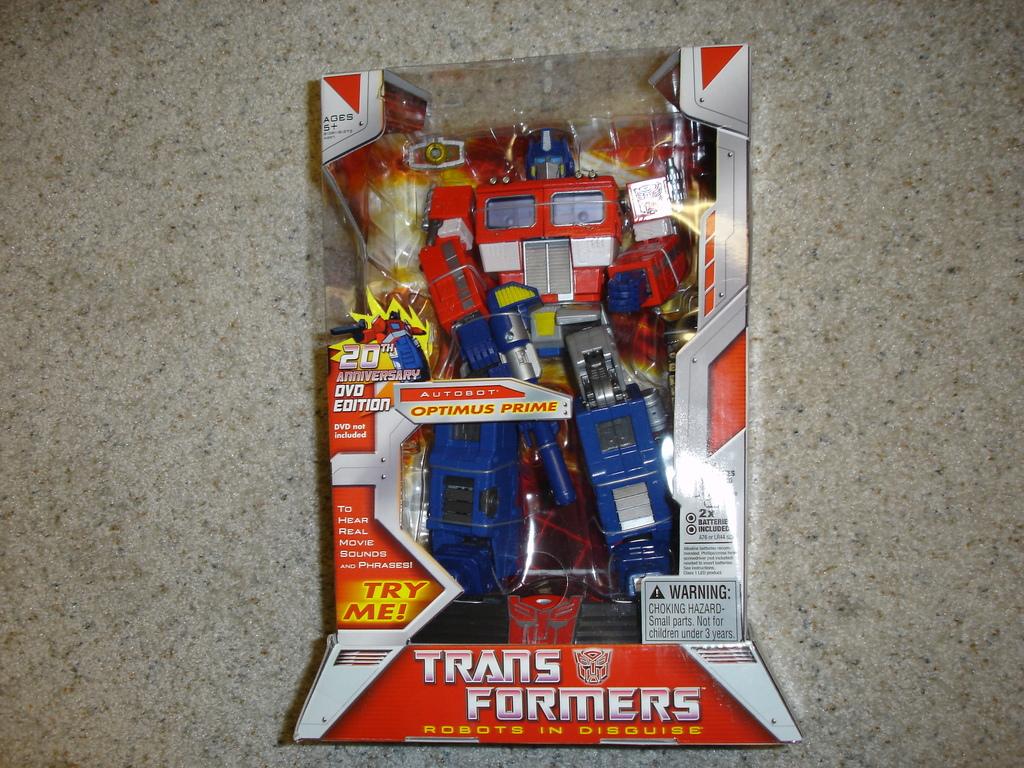Which transformer is this?
Make the answer very short. Optimus prime. What brand of toy is this?
Your answer should be compact. Transformers. 